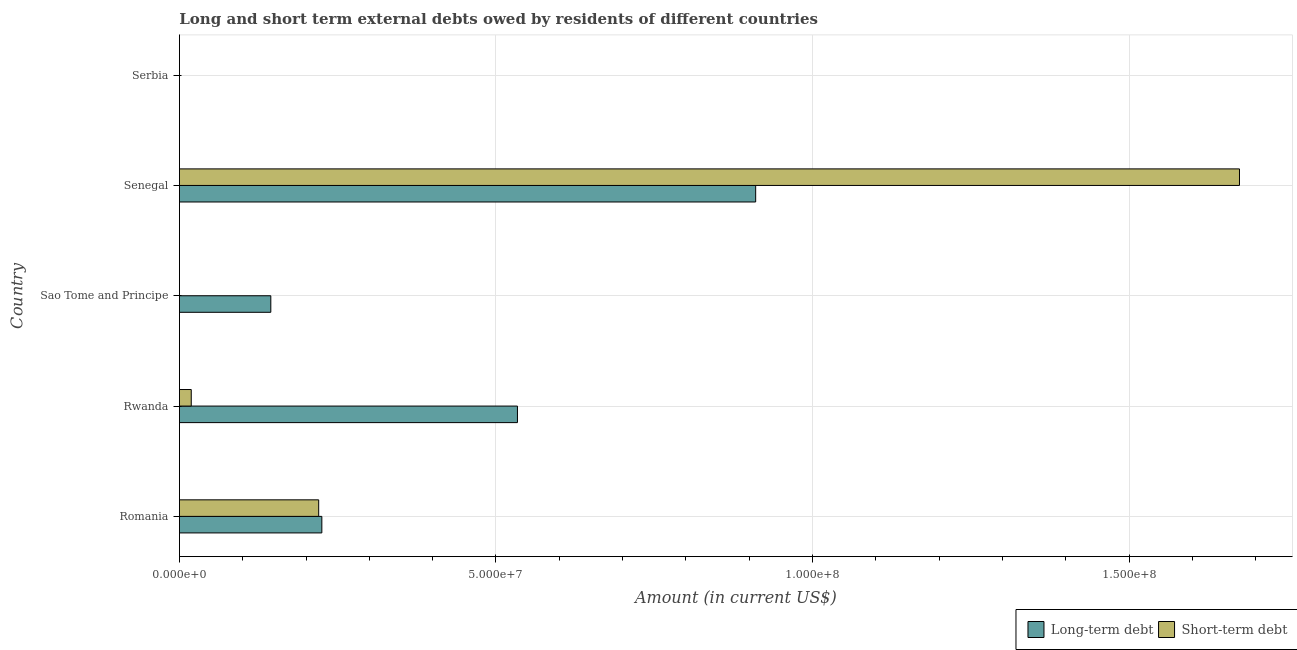How many different coloured bars are there?
Provide a succinct answer. 2. Are the number of bars per tick equal to the number of legend labels?
Offer a very short reply. No. Are the number of bars on each tick of the Y-axis equal?
Keep it short and to the point. No. What is the label of the 3rd group of bars from the top?
Keep it short and to the point. Sao Tome and Principe. What is the short-term debts owed by residents in Serbia?
Make the answer very short. 0. Across all countries, what is the maximum long-term debts owed by residents?
Offer a very short reply. 9.10e+07. In which country was the long-term debts owed by residents maximum?
Ensure brevity in your answer.  Senegal. What is the total short-term debts owed by residents in the graph?
Offer a terse response. 1.91e+08. What is the difference between the short-term debts owed by residents in Romania and that in Senegal?
Provide a short and direct response. -1.45e+08. What is the difference between the short-term debts owed by residents in Sao Tome and Principe and the long-term debts owed by residents in Romania?
Give a very brief answer. -2.25e+07. What is the average short-term debts owed by residents per country?
Make the answer very short. 3.83e+07. What is the difference between the short-term debts owed by residents and long-term debts owed by residents in Romania?
Your answer should be very brief. -4.99e+05. What is the ratio of the long-term debts owed by residents in Romania to that in Sao Tome and Principe?
Your answer should be compact. 1.56. Is the long-term debts owed by residents in Romania less than that in Sao Tome and Principe?
Keep it short and to the point. No. Is the difference between the long-term debts owed by residents in Romania and Senegal greater than the difference between the short-term debts owed by residents in Romania and Senegal?
Your answer should be compact. Yes. What is the difference between the highest and the second highest short-term debts owed by residents?
Offer a terse response. 1.45e+08. What is the difference between the highest and the lowest short-term debts owed by residents?
Provide a short and direct response. 1.67e+08. In how many countries, is the short-term debts owed by residents greater than the average short-term debts owed by residents taken over all countries?
Provide a short and direct response. 1. Is the sum of the long-term debts owed by residents in Romania and Sao Tome and Principe greater than the maximum short-term debts owed by residents across all countries?
Ensure brevity in your answer.  No. How many bars are there?
Give a very brief answer. 7. Are all the bars in the graph horizontal?
Offer a very short reply. Yes. How many countries are there in the graph?
Provide a short and direct response. 5. Are the values on the major ticks of X-axis written in scientific E-notation?
Make the answer very short. Yes. How many legend labels are there?
Your answer should be compact. 2. What is the title of the graph?
Your answer should be compact. Long and short term external debts owed by residents of different countries. Does "Secondary school" appear as one of the legend labels in the graph?
Keep it short and to the point. No. What is the Amount (in current US$) of Long-term debt in Romania?
Your answer should be compact. 2.25e+07. What is the Amount (in current US$) of Short-term debt in Romania?
Provide a succinct answer. 2.20e+07. What is the Amount (in current US$) of Long-term debt in Rwanda?
Make the answer very short. 5.34e+07. What is the Amount (in current US$) in Short-term debt in Rwanda?
Offer a terse response. 1.87e+06. What is the Amount (in current US$) of Long-term debt in Sao Tome and Principe?
Keep it short and to the point. 1.44e+07. What is the Amount (in current US$) in Short-term debt in Sao Tome and Principe?
Provide a succinct answer. 0. What is the Amount (in current US$) in Long-term debt in Senegal?
Provide a short and direct response. 9.10e+07. What is the Amount (in current US$) in Short-term debt in Senegal?
Your answer should be very brief. 1.67e+08. What is the Amount (in current US$) of Long-term debt in Serbia?
Keep it short and to the point. 0. Across all countries, what is the maximum Amount (in current US$) in Long-term debt?
Your answer should be compact. 9.10e+07. Across all countries, what is the maximum Amount (in current US$) of Short-term debt?
Ensure brevity in your answer.  1.67e+08. Across all countries, what is the minimum Amount (in current US$) of Long-term debt?
Ensure brevity in your answer.  0. What is the total Amount (in current US$) of Long-term debt in the graph?
Make the answer very short. 1.81e+08. What is the total Amount (in current US$) of Short-term debt in the graph?
Your answer should be compact. 1.91e+08. What is the difference between the Amount (in current US$) in Long-term debt in Romania and that in Rwanda?
Provide a succinct answer. -3.09e+07. What is the difference between the Amount (in current US$) in Short-term debt in Romania and that in Rwanda?
Your response must be concise. 2.01e+07. What is the difference between the Amount (in current US$) in Long-term debt in Romania and that in Sao Tome and Principe?
Make the answer very short. 8.06e+06. What is the difference between the Amount (in current US$) of Long-term debt in Romania and that in Senegal?
Provide a succinct answer. -6.85e+07. What is the difference between the Amount (in current US$) in Short-term debt in Romania and that in Senegal?
Provide a succinct answer. -1.45e+08. What is the difference between the Amount (in current US$) in Long-term debt in Rwanda and that in Sao Tome and Principe?
Your answer should be very brief. 3.90e+07. What is the difference between the Amount (in current US$) in Long-term debt in Rwanda and that in Senegal?
Ensure brevity in your answer.  -3.76e+07. What is the difference between the Amount (in current US$) of Short-term debt in Rwanda and that in Senegal?
Your response must be concise. -1.66e+08. What is the difference between the Amount (in current US$) in Long-term debt in Sao Tome and Principe and that in Senegal?
Provide a succinct answer. -7.66e+07. What is the difference between the Amount (in current US$) of Long-term debt in Romania and the Amount (in current US$) of Short-term debt in Rwanda?
Ensure brevity in your answer.  2.06e+07. What is the difference between the Amount (in current US$) in Long-term debt in Romania and the Amount (in current US$) in Short-term debt in Senegal?
Provide a short and direct response. -1.45e+08. What is the difference between the Amount (in current US$) in Long-term debt in Rwanda and the Amount (in current US$) in Short-term debt in Senegal?
Give a very brief answer. -1.14e+08. What is the difference between the Amount (in current US$) of Long-term debt in Sao Tome and Principe and the Amount (in current US$) of Short-term debt in Senegal?
Offer a very short reply. -1.53e+08. What is the average Amount (in current US$) of Long-term debt per country?
Provide a short and direct response. 3.63e+07. What is the average Amount (in current US$) in Short-term debt per country?
Offer a very short reply. 3.83e+07. What is the difference between the Amount (in current US$) of Long-term debt and Amount (in current US$) of Short-term debt in Romania?
Keep it short and to the point. 4.99e+05. What is the difference between the Amount (in current US$) of Long-term debt and Amount (in current US$) of Short-term debt in Rwanda?
Offer a terse response. 5.15e+07. What is the difference between the Amount (in current US$) of Long-term debt and Amount (in current US$) of Short-term debt in Senegal?
Give a very brief answer. -7.64e+07. What is the ratio of the Amount (in current US$) of Long-term debt in Romania to that in Rwanda?
Your answer should be compact. 0.42. What is the ratio of the Amount (in current US$) of Short-term debt in Romania to that in Rwanda?
Provide a short and direct response. 11.76. What is the ratio of the Amount (in current US$) of Long-term debt in Romania to that in Sao Tome and Principe?
Your response must be concise. 1.56. What is the ratio of the Amount (in current US$) of Long-term debt in Romania to that in Senegal?
Keep it short and to the point. 0.25. What is the ratio of the Amount (in current US$) of Short-term debt in Romania to that in Senegal?
Your response must be concise. 0.13. What is the ratio of the Amount (in current US$) of Long-term debt in Rwanda to that in Sao Tome and Principe?
Provide a succinct answer. 3.7. What is the ratio of the Amount (in current US$) in Long-term debt in Rwanda to that in Senegal?
Keep it short and to the point. 0.59. What is the ratio of the Amount (in current US$) of Short-term debt in Rwanda to that in Senegal?
Your answer should be compact. 0.01. What is the ratio of the Amount (in current US$) of Long-term debt in Sao Tome and Principe to that in Senegal?
Offer a very short reply. 0.16. What is the difference between the highest and the second highest Amount (in current US$) of Long-term debt?
Your answer should be compact. 3.76e+07. What is the difference between the highest and the second highest Amount (in current US$) in Short-term debt?
Keep it short and to the point. 1.45e+08. What is the difference between the highest and the lowest Amount (in current US$) in Long-term debt?
Your answer should be compact. 9.10e+07. What is the difference between the highest and the lowest Amount (in current US$) in Short-term debt?
Offer a very short reply. 1.67e+08. 